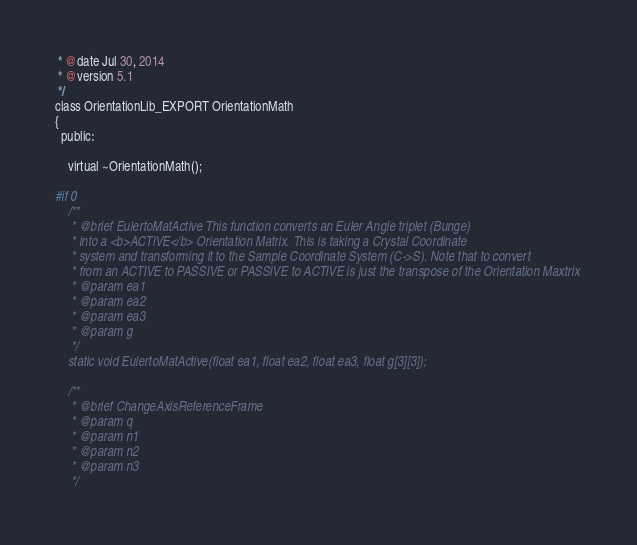Convert code to text. <code><loc_0><loc_0><loc_500><loc_500><_C_> * @date Jul 30, 2014
 * @version 5.1
 */
class OrientationLib_EXPORT OrientationMath
{
  public:

    virtual ~OrientationMath();

#if 0
    /**
     * @brief EulertoMatActive This function converts an Euler Angle triplet (Bunge)
     * into a <b>ACTIVE</b> Orientation Matrix. This is taking a Crystal Coordinate
     * system and transforming it to the Sample Coordinate System (C->S). Note that to convert
     * from an ACTIVE to PASSIVE or PASSIVE to ACTIVE is just the transpose of the Orientation Maxtrix
     * @param ea1
     * @param ea2
     * @param ea3
     * @param g
     */
    static void EulertoMatActive(float ea1, float ea2, float ea3, float g[3][3]);

    /**
     * @brief ChangeAxisReferenceFrame
     * @param q
     * @param n1
     * @param n2
     * @param n3
     */</code> 